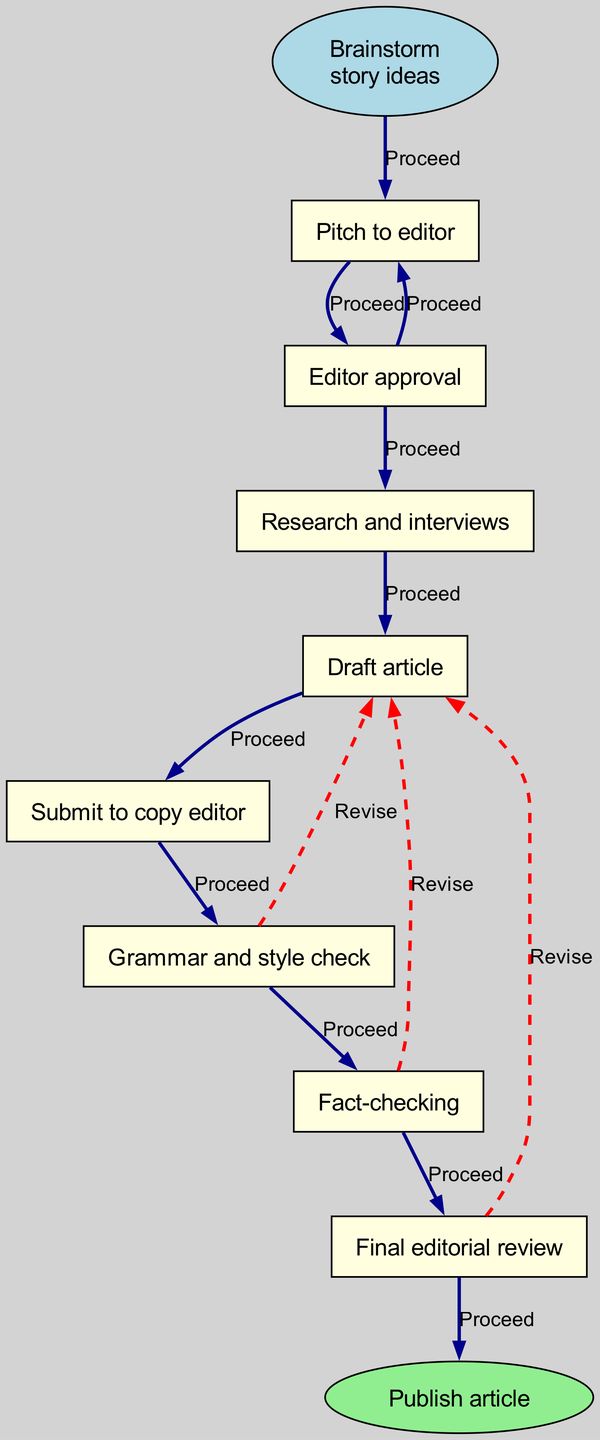What is the first step in the journey of a news article? The first step is to brainstorm story ideas, which is the starting point of the flow chart.
Answer: Brainstorm story ideas How many main stages are there before publication? The diagram contains multiple stages, but counting the nodes before reaching the final publication stage shows there are nine stages.
Answer: Nine What action happens after the editor approval stage? After editor approval, the next step is to conduct research and interviews, as indicated in the flow sequence.
Answer: Research and interviews What happens if the grammar and style check fails? If the grammar and style check fails, the article goes back to the drafting stage as indicated by the red dashed line connecting the nodes.
Answer: Revise What is the final action in the flowchart? The final action indicated in the flowchart is to publish the article, which is noted as the last step before finishing the process.
Answer: Publish article What type of review happens after fact-checking? The type of review that follows fact-checking is the final editorial review, marking an essential checkpoint before publication.
Answer: Final editorial review How many steps can a writer take after submission to the copy editor? After submission to the copy editor, the writer has two potential steps: grammar and style check or returning to draft the article if there are issues, which makes two pathways.
Answer: Two Which step directly precedes the final editorial review? The step that directly precedes the final editorial review is fact-checking, as each stage of the flowchart progresses logically to the next.
Answer: Fact-checking What two outcomes can occur after the editor approval step? After the editor approval step, the article can either proceed to research and interviews or go back to pitching, indicated by the two connecting arrows.
Answer: Research and interviews or Pitch to editor 